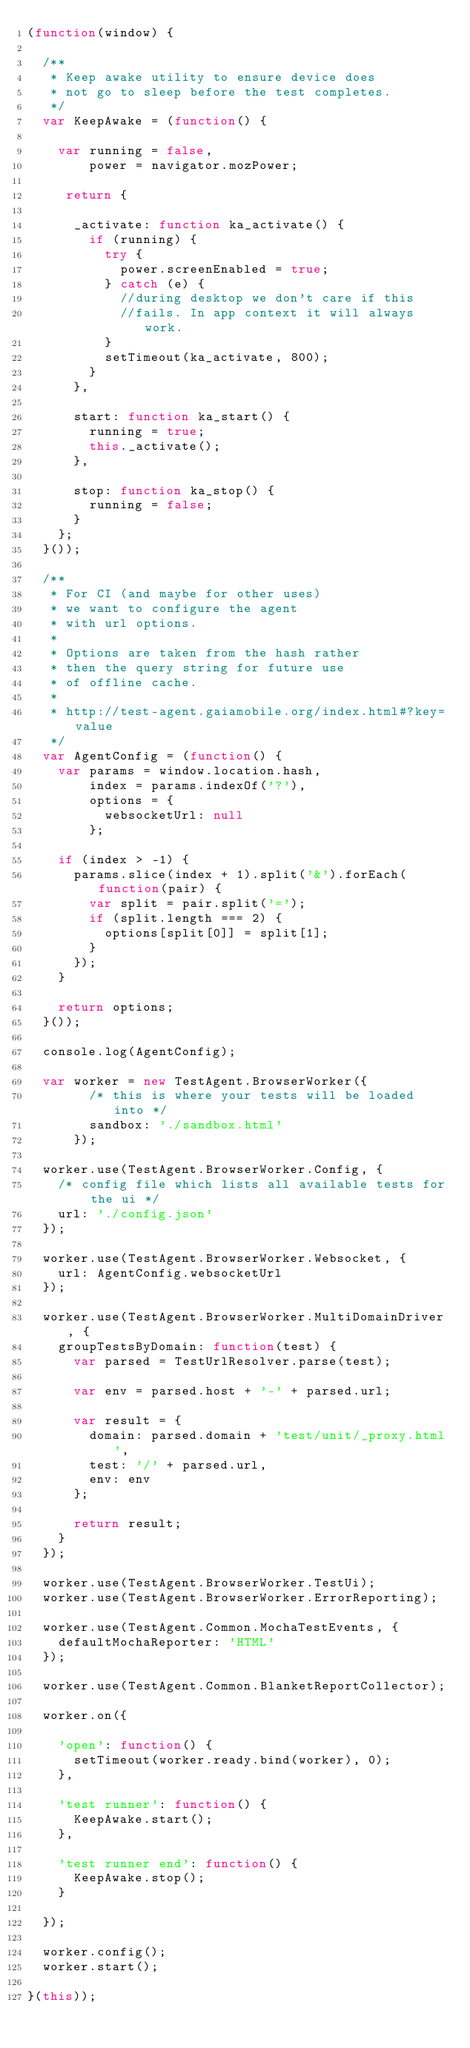<code> <loc_0><loc_0><loc_500><loc_500><_JavaScript_>(function(window) {

  /**
   * Keep awake utility to ensure device does
   * not go to sleep before the test completes.
   */
  var KeepAwake = (function() {

    var running = false,
        power = navigator.mozPower;

     return {

      _activate: function ka_activate() {
        if (running) {
          try {
            power.screenEnabled = true;
          } catch (e) {
            //during desktop we don't care if this
            //fails. In app context it will always work.
          }
          setTimeout(ka_activate, 800);
        }
      },

      start: function ka_start() {
        running = true;
        this._activate();
      },

      stop: function ka_stop() {
        running = false;
      }
    };
  }());

  /**
   * For CI (and maybe for other uses)
   * we want to configure the agent
   * with url options.
   *
   * Options are taken from the hash rather
   * then the query string for future use
   * of offline cache.
   *
   * http://test-agent.gaiamobile.org/index.html#?key=value
   */
  var AgentConfig = (function() {
    var params = window.location.hash,
        index = params.indexOf('?'),
        options = {
          websocketUrl: null
        };

    if (index > -1) {
      params.slice(index + 1).split('&').forEach(function(pair) {
        var split = pair.split('=');
        if (split.length === 2) {
          options[split[0]] = split[1];
        }
      });
    }

    return options;
  }());

  console.log(AgentConfig);

  var worker = new TestAgent.BrowserWorker({
        /* this is where your tests will be loaded into */
        sandbox: './sandbox.html'
      });

  worker.use(TestAgent.BrowserWorker.Config, {
    /* config file which lists all available tests for the ui */
    url: './config.json'
  });

  worker.use(TestAgent.BrowserWorker.Websocket, {
    url: AgentConfig.websocketUrl
  });

  worker.use(TestAgent.BrowserWorker.MultiDomainDriver, {
    groupTestsByDomain: function(test) {
      var parsed = TestUrlResolver.parse(test);

      var env = parsed.host + '-' + parsed.url;

      var result = {
        domain: parsed.domain + 'test/unit/_proxy.html',
        test: '/' + parsed.url,
        env: env
      };

      return result;
    }
  });

  worker.use(TestAgent.BrowserWorker.TestUi);
  worker.use(TestAgent.BrowserWorker.ErrorReporting);

  worker.use(TestAgent.Common.MochaTestEvents, {
    defaultMochaReporter: 'HTML'
  });

  worker.use(TestAgent.Common.BlanketReportCollector);

  worker.on({

    'open': function() {
      setTimeout(worker.ready.bind(worker), 0);
    },

    'test runner': function() {
      KeepAwake.start();
    },

    'test runner end': function() {
      KeepAwake.stop();
    }

  });

  worker.config();
  worker.start();

}(this));

</code> 